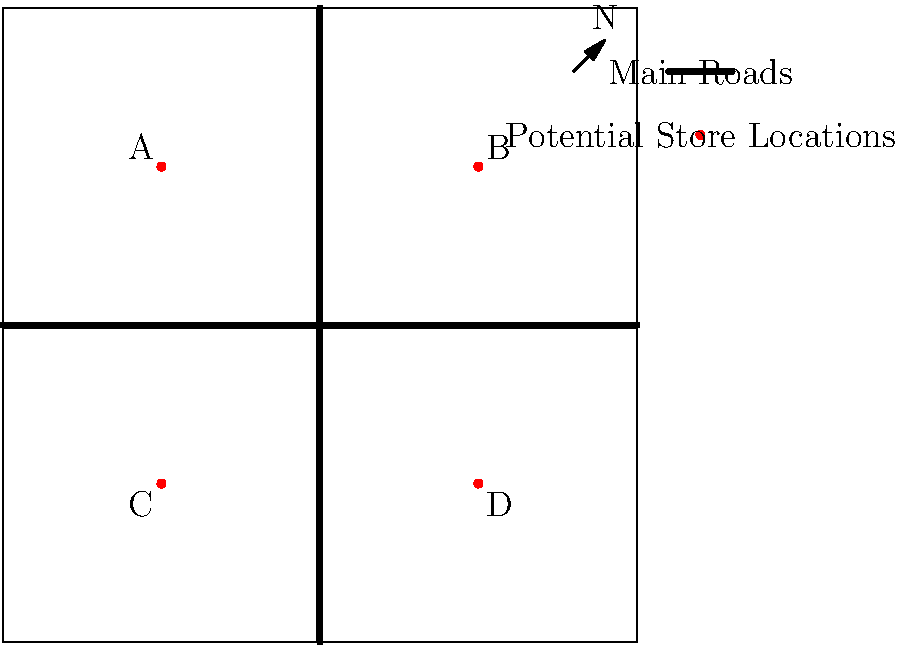Based on the Worcester city map provided, which two store locations would be most optimal for expanding your brand's presence, considering traffic flow and accessibility? To determine the optimal store locations, we need to consider several factors:

1. Traffic flow: The map shows two main roads intersecting at the center, indicating high traffic areas.

2. Accessibility: Locations near the intersection of main roads are more accessible to customers.

3. Coverage: Choosing locations that are not too close to each other ensures better coverage of the city.

4. Quadrant distribution: Selecting locations in different quadrants of the city can help reach diverse customer bases.

Analyzing the potential locations:

A (25,75): Located in the northwest quadrant, near one main road.
B (75,75): Located in the northeast quadrant, near one main road.
C (25,25): Located in the southwest quadrant, near one main road.
D (75,25): Located in the southeast quadrant, near one main road.

The most optimal choices would be:

1. Location B (75,75): It's in the northeast quadrant and close to both main roads, providing high traffic and accessibility.

2. Location C (25,25): It's in the southwest quadrant, providing good coverage of the opposite side of the city from Location B. It's also near one main road for accessibility.

These two locations offer the best combination of traffic flow, accessibility, coverage, and quadrant distribution for expanding the brand's presence in Worcester.
Answer: Locations B and C 